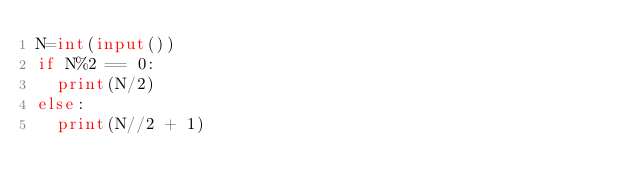Convert code to text. <code><loc_0><loc_0><loc_500><loc_500><_Python_>N=int(input())
if N%2 == 0:
  print(N/2)
else:
  print(N//2 + 1)</code> 